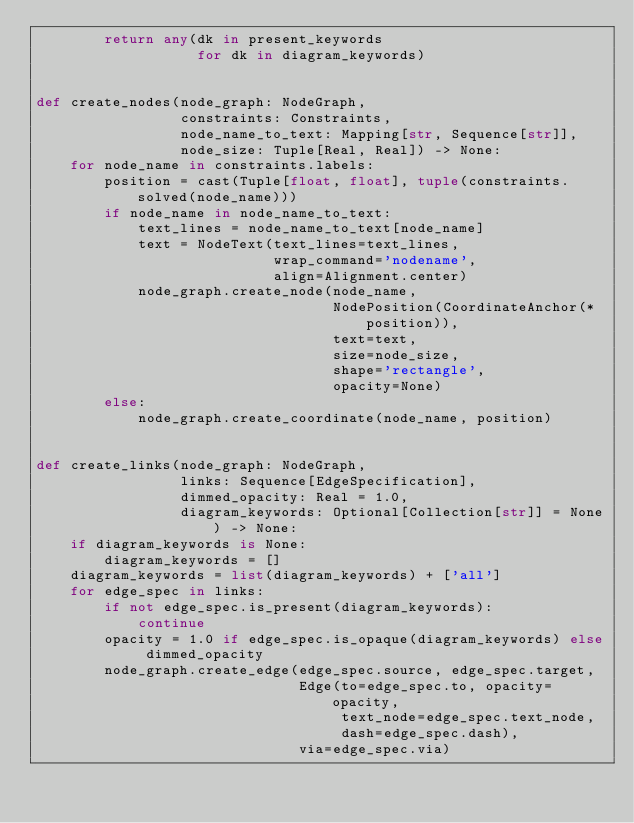<code> <loc_0><loc_0><loc_500><loc_500><_Python_>        return any(dk in present_keywords
                   for dk in diagram_keywords)


def create_nodes(node_graph: NodeGraph,
                 constraints: Constraints,
                 node_name_to_text: Mapping[str, Sequence[str]],
                 node_size: Tuple[Real, Real]) -> None:
    for node_name in constraints.labels:
        position = cast(Tuple[float, float], tuple(constraints.solved(node_name)))
        if node_name in node_name_to_text:
            text_lines = node_name_to_text[node_name]
            text = NodeText(text_lines=text_lines,
                            wrap_command='nodename',
                            align=Alignment.center)
            node_graph.create_node(node_name,
                                   NodePosition(CoordinateAnchor(*position)),
                                   text=text,
                                   size=node_size,
                                   shape='rectangle',
                                   opacity=None)
        else:
            node_graph.create_coordinate(node_name, position)


def create_links(node_graph: NodeGraph,
                 links: Sequence[EdgeSpecification],
                 dimmed_opacity: Real = 1.0,
                 diagram_keywords: Optional[Collection[str]] = None) -> None:
    if diagram_keywords is None:
        diagram_keywords = []
    diagram_keywords = list(diagram_keywords) + ['all']
    for edge_spec in links:
        if not edge_spec.is_present(diagram_keywords):
            continue
        opacity = 1.0 if edge_spec.is_opaque(diagram_keywords) else dimmed_opacity
        node_graph.create_edge(edge_spec.source, edge_spec.target,
                               Edge(to=edge_spec.to, opacity=opacity,
                                    text_node=edge_spec.text_node,
                                    dash=edge_spec.dash),
                               via=edge_spec.via)
</code> 